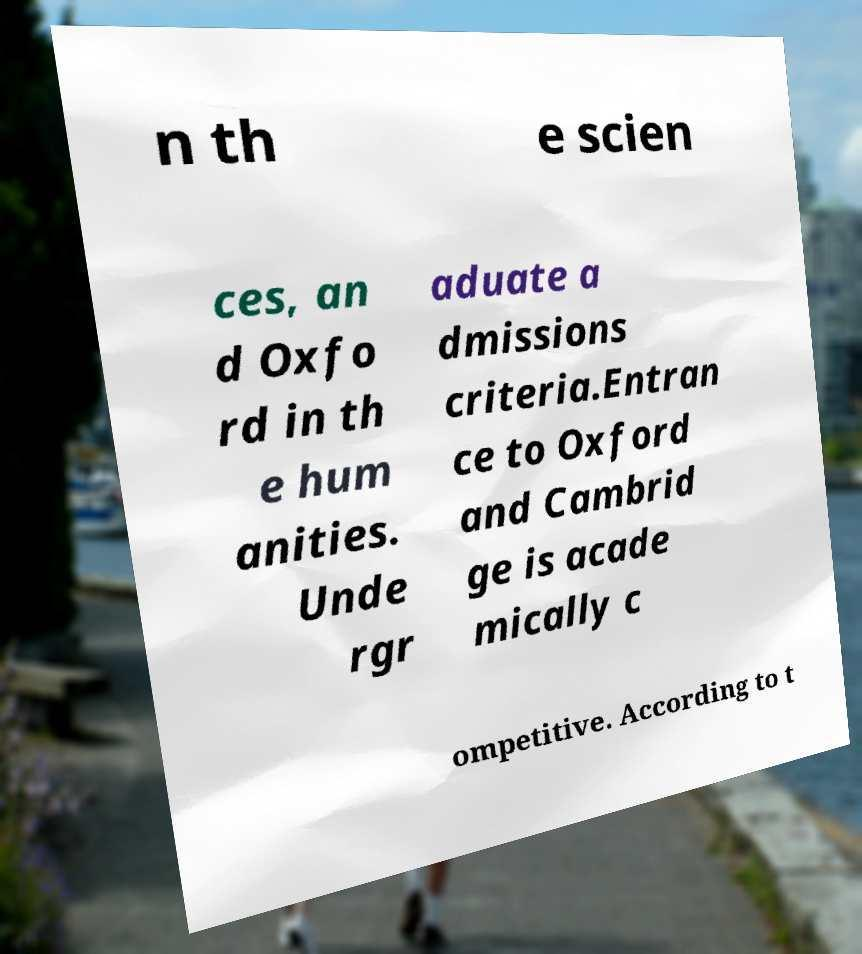Please identify and transcribe the text found in this image. n th e scien ces, an d Oxfo rd in th e hum anities. Unde rgr aduate a dmissions criteria.Entran ce to Oxford and Cambrid ge is acade mically c ompetitive. According to t 